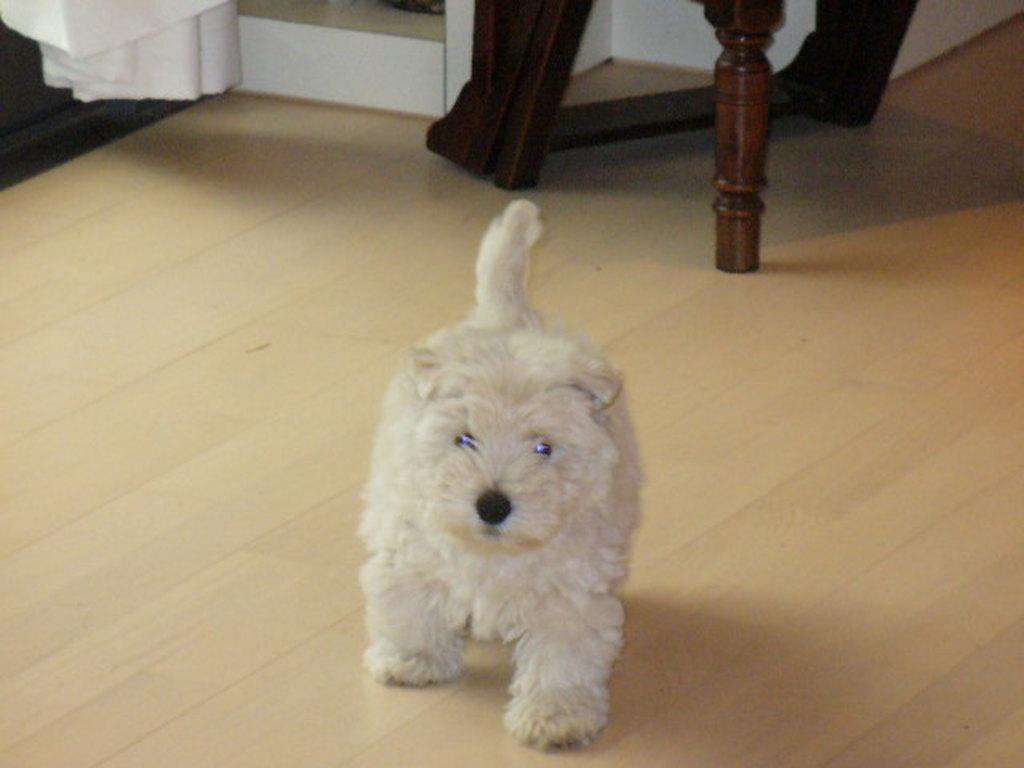What animal is present in the image? There is a dog in the image. Where is the dog located? The dog is on the floor. What type of material can be seen in the background of the image? Cloth is visible in the background of the image. What other objects can be seen in the background of the image? There are wooden sticks in the background of the image. How many faces can be seen in the image? There are no faces present in the image; it features a dog on the floor. What type of heart is visible in the image? There is no heart present in the image. 